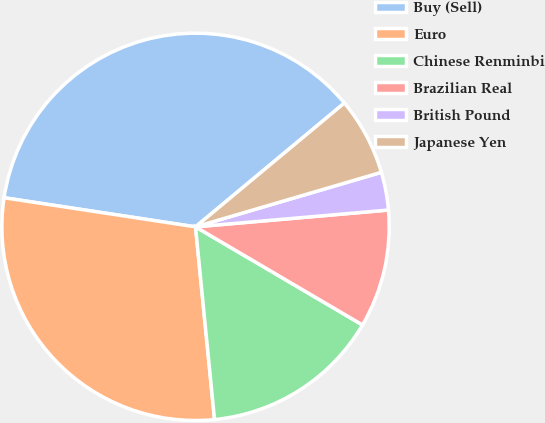<chart> <loc_0><loc_0><loc_500><loc_500><pie_chart><fcel>Buy (Sell)<fcel>Euro<fcel>Chinese Renminbi<fcel>Brazilian Real<fcel>British Pound<fcel>Japanese Yen<nl><fcel>36.56%<fcel>28.97%<fcel>14.98%<fcel>9.84%<fcel>3.16%<fcel>6.5%<nl></chart> 